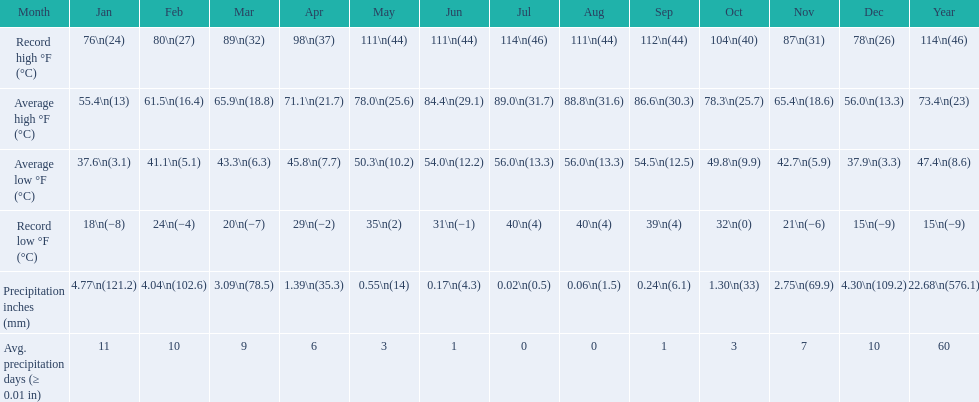0 degrees and the mean low hit 5 July. 